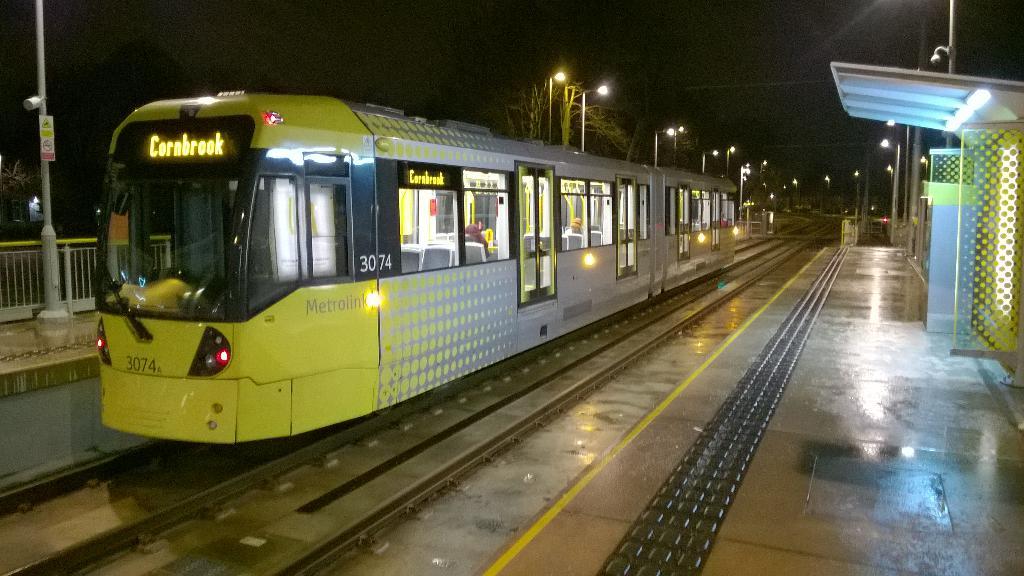Where is the train heading?
Your answer should be compact. Cornbrook. What is the number of the train?
Provide a succinct answer. 3074. 